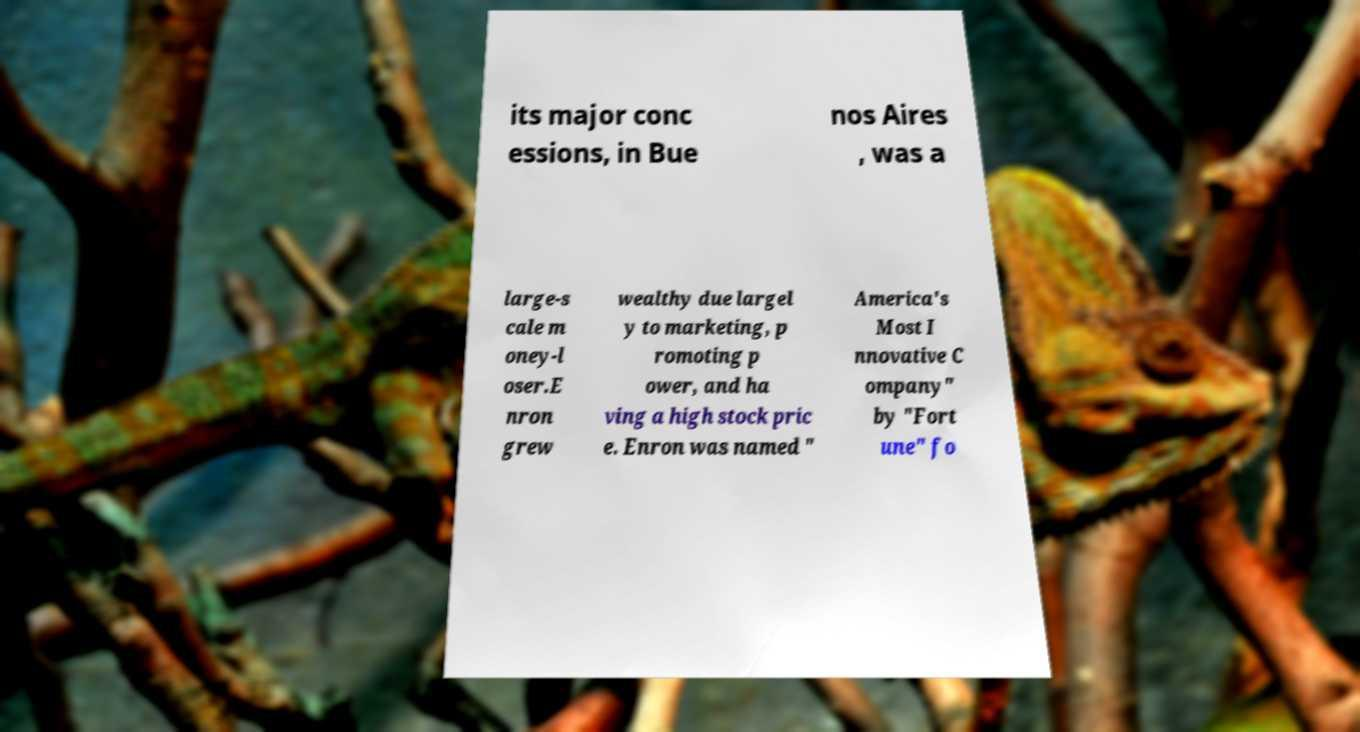There's text embedded in this image that I need extracted. Can you transcribe it verbatim? its major conc essions, in Bue nos Aires , was a large-s cale m oney-l oser.E nron grew wealthy due largel y to marketing, p romoting p ower, and ha ving a high stock pric e. Enron was named " America's Most I nnovative C ompany" by "Fort une" fo 